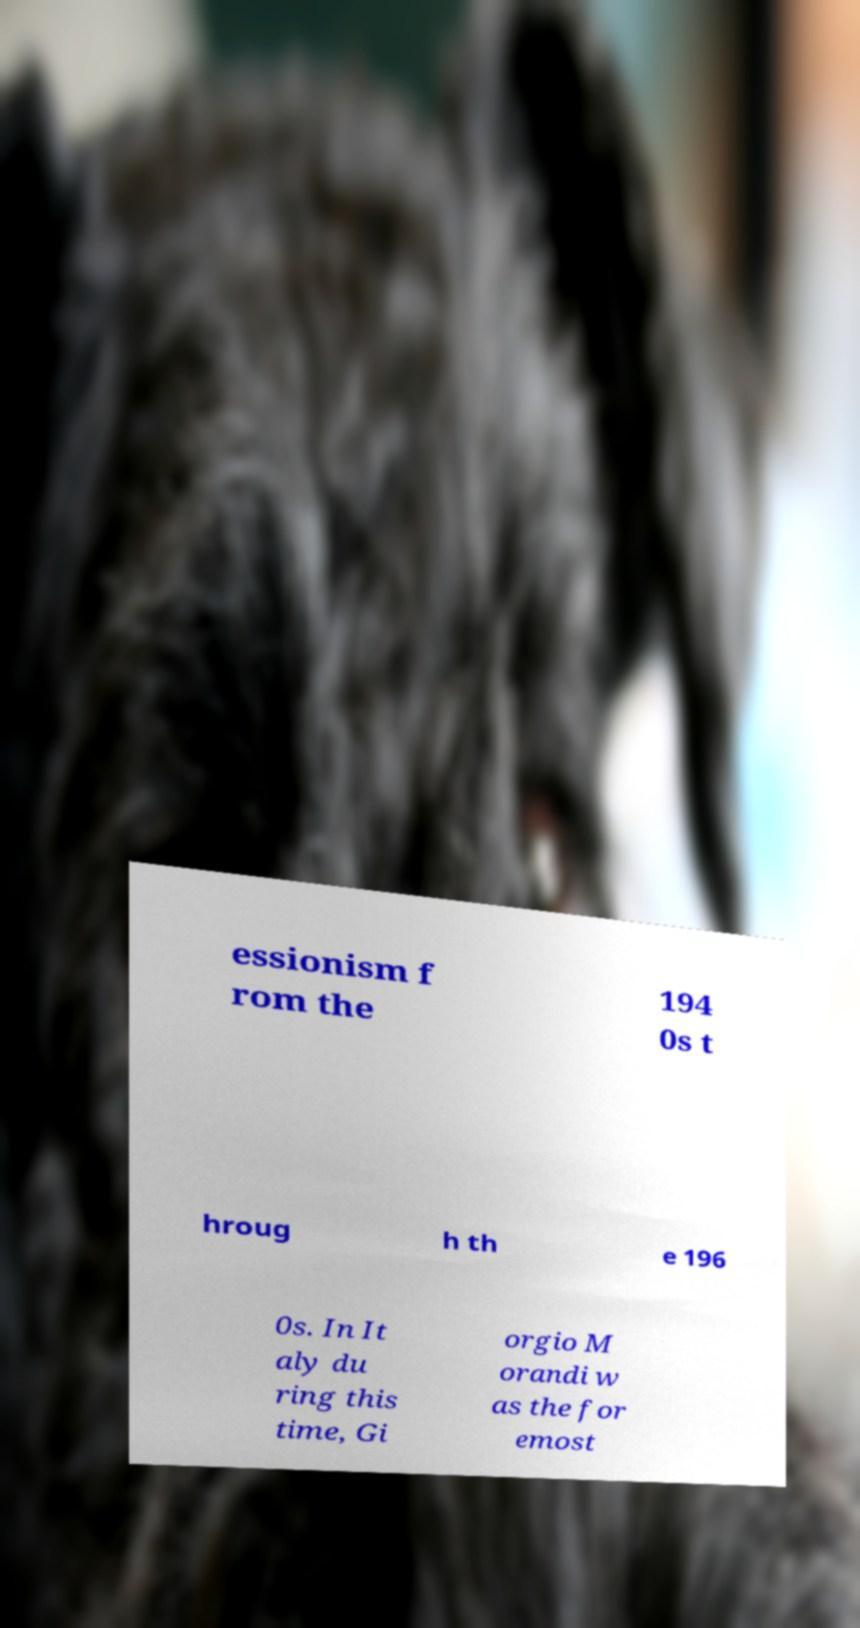Please identify and transcribe the text found in this image. essionism f rom the 194 0s t hroug h th e 196 0s. In It aly du ring this time, Gi orgio M orandi w as the for emost 